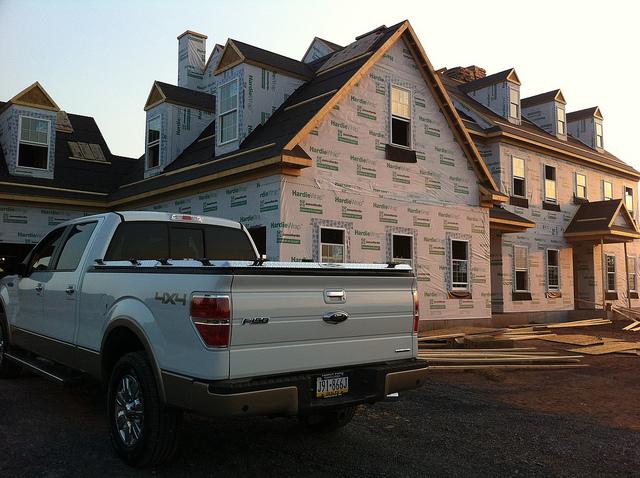Is the house finished?
Quick response, please. No. How many windows are open on the second floor?
Concise answer only. 6. What brand is the truck?
Write a very short answer. Ford. 